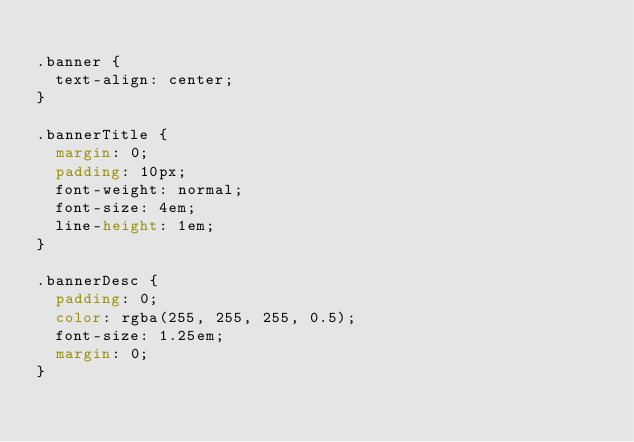Convert code to text. <code><loc_0><loc_0><loc_500><loc_500><_CSS_>
.banner {
  text-align: center;
}

.bannerTitle {
  margin: 0;
  padding: 10px;
  font-weight: normal;
  font-size: 4em;
  line-height: 1em;
}

.bannerDesc {
  padding: 0;
  color: rgba(255, 255, 255, 0.5);
  font-size: 1.25em;
  margin: 0;
}
</code> 